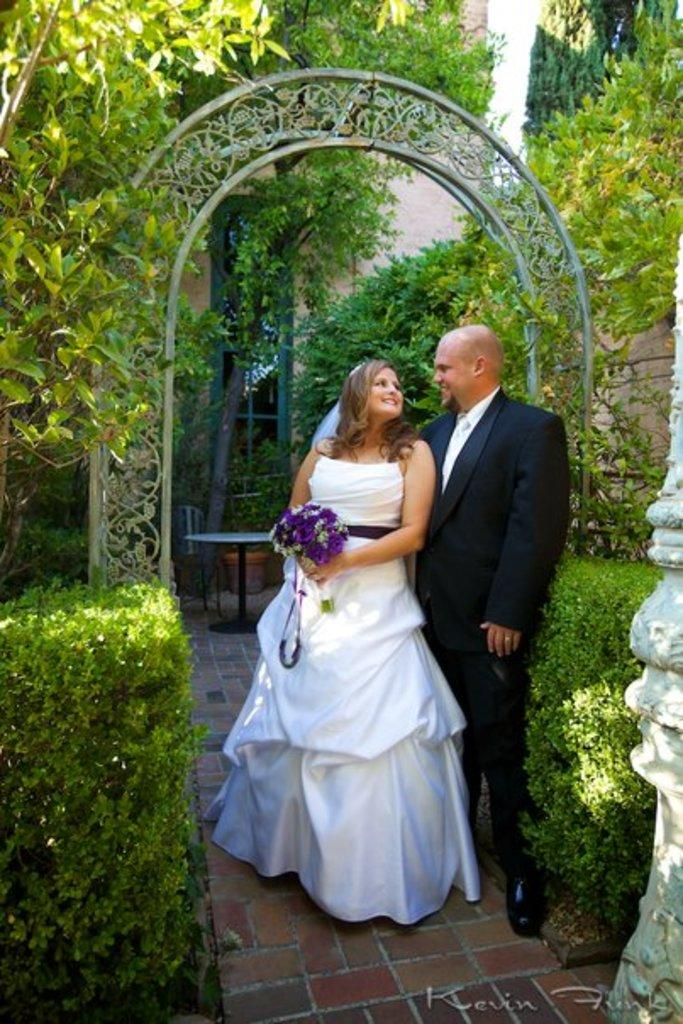What can be seen in the image that represents a collection of flowers? There is a flower bouquet in the image. What type of furniture is present in the image? There is a table and a chair in the image. What architectural feature is visible in the image? There is an arch in the image. What type of vegetation can be seen in the image? There are plants and trees in the image. How many people are present in the image? There are two people standing in the image. What is the facial expression of the people in the image? The people are smiling. What can be seen in the background of the image? There is a wall and a window in the background of the image. What type of army is marching through the flower bouquet in the image? There is no army present in the image; it features a flower bouquet, a table, a chair, an arch, plants, trees, two smiling people, a wall, and a window in the background. What is the temperature in the image? The provided facts do not mention the temperature or heat in the image, so it cannot be determined. 